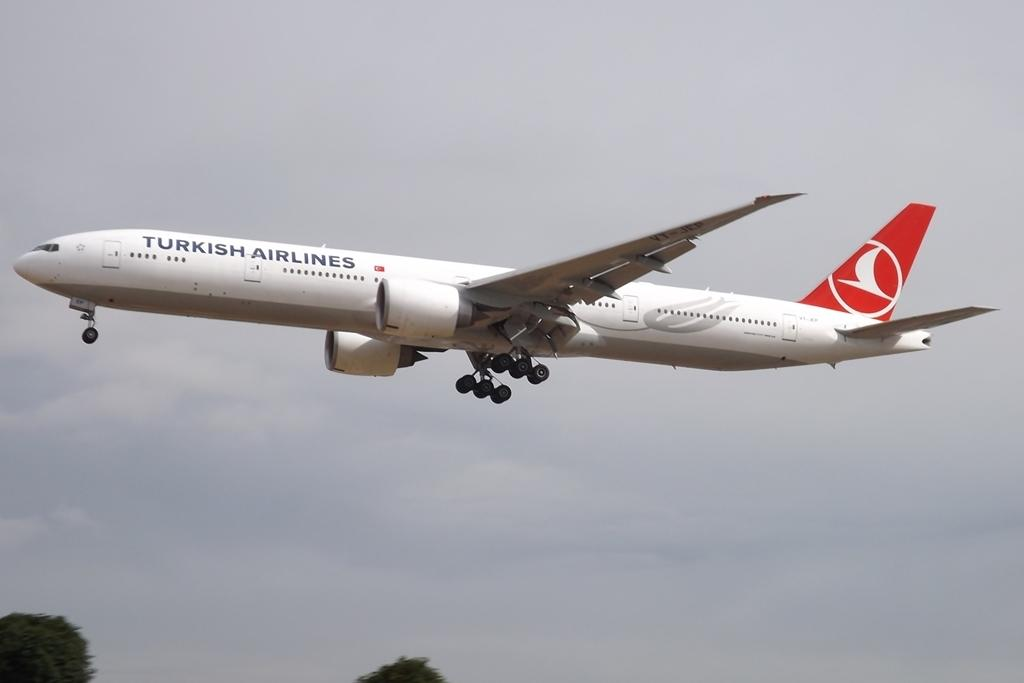<image>
Give a short and clear explanation of the subsequent image. a very large TURKISH AIRLINES airplane in the air. 